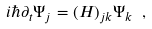Convert formula to latex. <formula><loc_0><loc_0><loc_500><loc_500>i \hbar { \partial } _ { t } \Psi _ { j } = ( H ) _ { j k } \Psi _ { k } \ ,</formula> 